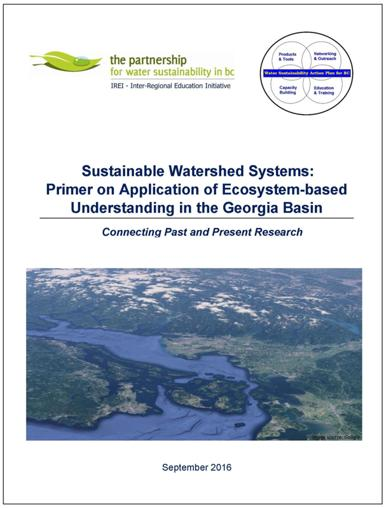What might be some challenges addressed in this publication regarding watershed sustainability? Considering the focus on ecosystem-based understanding, this publication is likely to address challenges such as the impact of human activities on water quality, the need for integrated management practices, issues related to habitat conservation, and the balancing of different economic and social interests in watershed planning and preservation. 